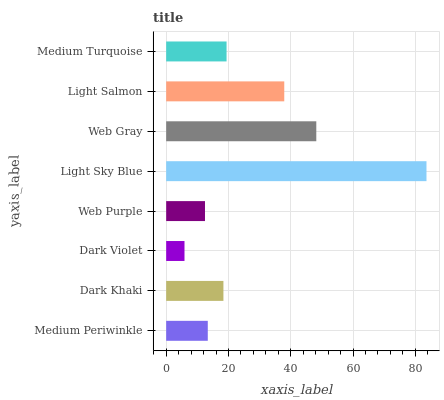Is Dark Violet the minimum?
Answer yes or no. Yes. Is Light Sky Blue the maximum?
Answer yes or no. Yes. Is Dark Khaki the minimum?
Answer yes or no. No. Is Dark Khaki the maximum?
Answer yes or no. No. Is Dark Khaki greater than Medium Periwinkle?
Answer yes or no. Yes. Is Medium Periwinkle less than Dark Khaki?
Answer yes or no. Yes. Is Medium Periwinkle greater than Dark Khaki?
Answer yes or no. No. Is Dark Khaki less than Medium Periwinkle?
Answer yes or no. No. Is Medium Turquoise the high median?
Answer yes or no. Yes. Is Dark Khaki the low median?
Answer yes or no. Yes. Is Light Sky Blue the high median?
Answer yes or no. No. Is Web Purple the low median?
Answer yes or no. No. 